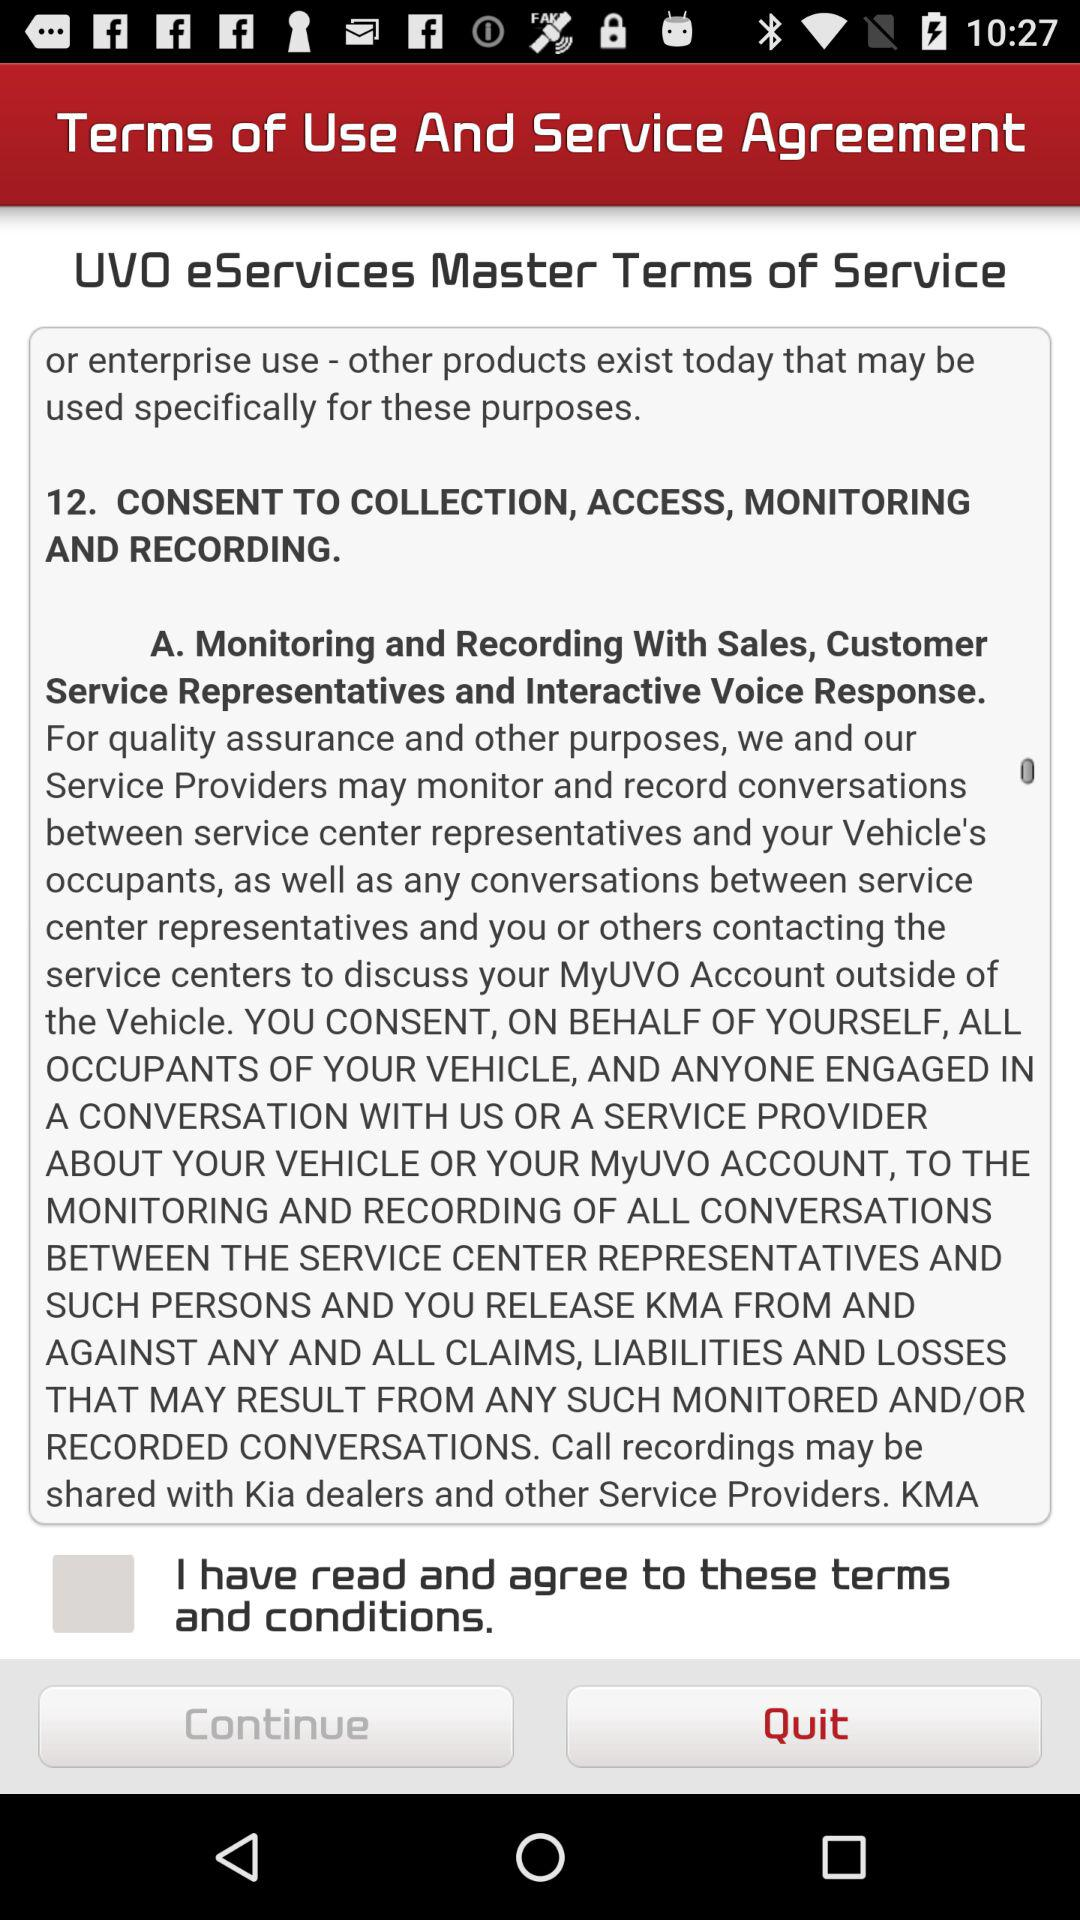What is the status of "I have read and agree to these terms and conditions."? The status is "off". 